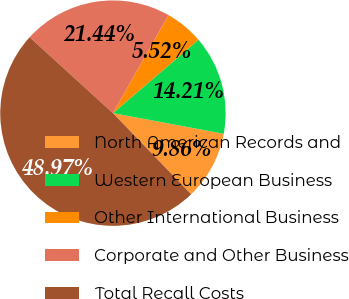Convert chart to OTSL. <chart><loc_0><loc_0><loc_500><loc_500><pie_chart><fcel>North American Records and<fcel>Western European Business<fcel>Other International Business<fcel>Corporate and Other Business<fcel>Total Recall Costs<nl><fcel>9.86%<fcel>14.21%<fcel>5.52%<fcel>21.44%<fcel>48.97%<nl></chart> 